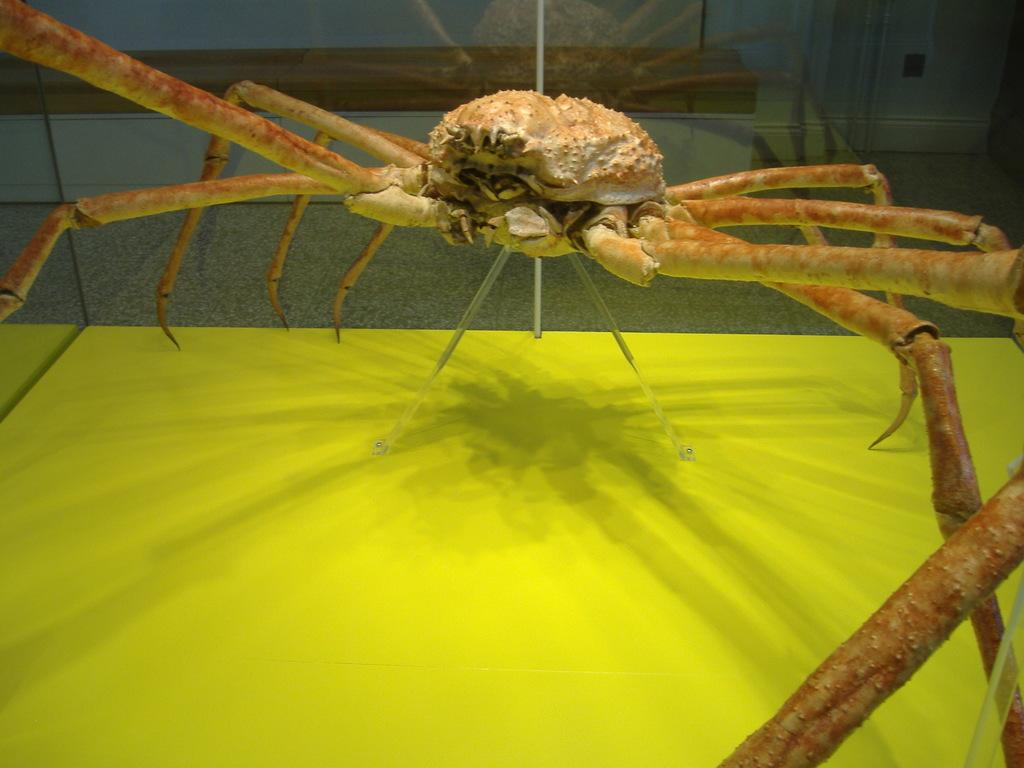What type of creature is present in the image? There is an insect in the image. What is the color of the insect? The insect is brown in color. What is the color of the floor in the image? The floor in the image is green in color. What type of ice can be seen melting on the floor in the image? There is no ice present in the image, and therefore no ice can be seen melting on the floor. How many giants are visible in the image? There are no giants present in the image. 